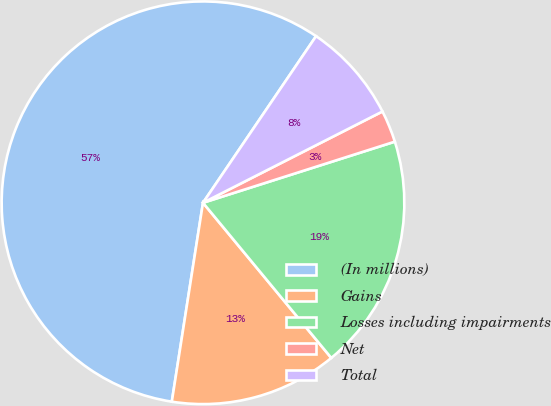Convert chart to OTSL. <chart><loc_0><loc_0><loc_500><loc_500><pie_chart><fcel>(In millions)<fcel>Gains<fcel>Losses including impairments<fcel>Net<fcel>Total<nl><fcel>57.01%<fcel>13.47%<fcel>18.91%<fcel>2.58%<fcel>8.02%<nl></chart> 